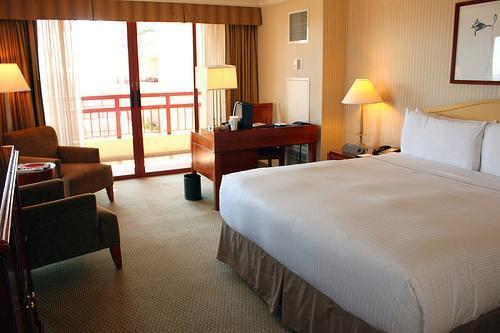How many pillows are on the bed?
Give a very brief answer. 2. 